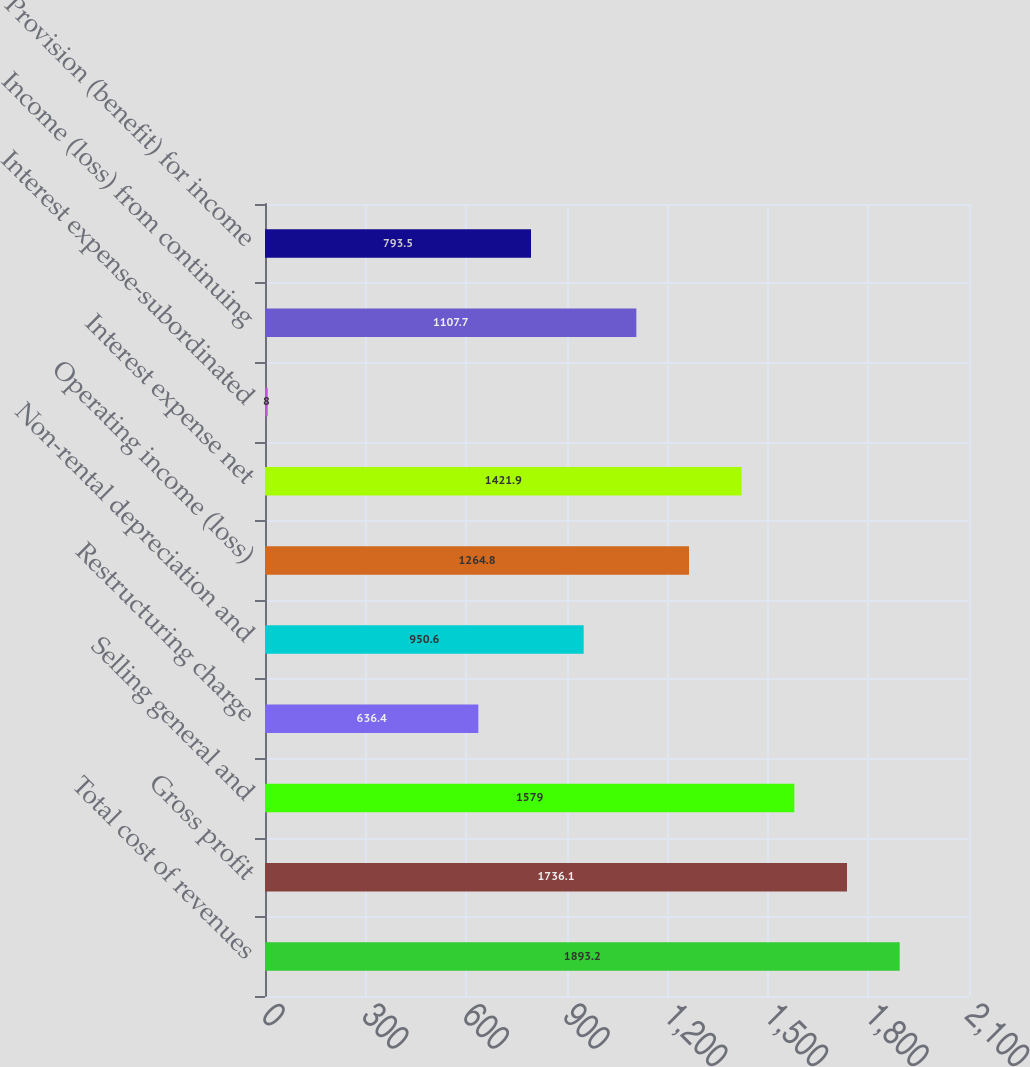Convert chart. <chart><loc_0><loc_0><loc_500><loc_500><bar_chart><fcel>Total cost of revenues<fcel>Gross profit<fcel>Selling general and<fcel>Restructuring charge<fcel>Non-rental depreciation and<fcel>Operating income (loss)<fcel>Interest expense net<fcel>Interest expense-subordinated<fcel>Income (loss) from continuing<fcel>Provision (benefit) for income<nl><fcel>1893.2<fcel>1736.1<fcel>1579<fcel>636.4<fcel>950.6<fcel>1264.8<fcel>1421.9<fcel>8<fcel>1107.7<fcel>793.5<nl></chart> 